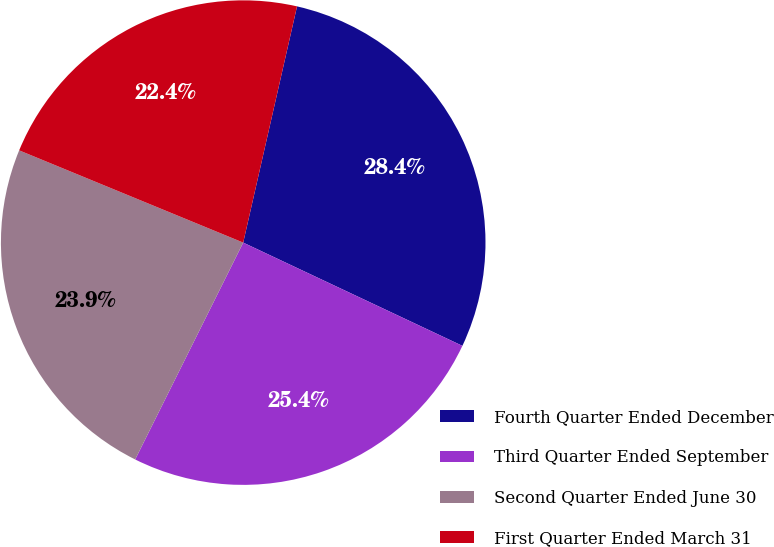Convert chart. <chart><loc_0><loc_0><loc_500><loc_500><pie_chart><fcel>Fourth Quarter Ended December<fcel>Third Quarter Ended September<fcel>Second Quarter Ended June 30<fcel>First Quarter Ended March 31<nl><fcel>28.44%<fcel>25.35%<fcel>23.86%<fcel>22.35%<nl></chart> 